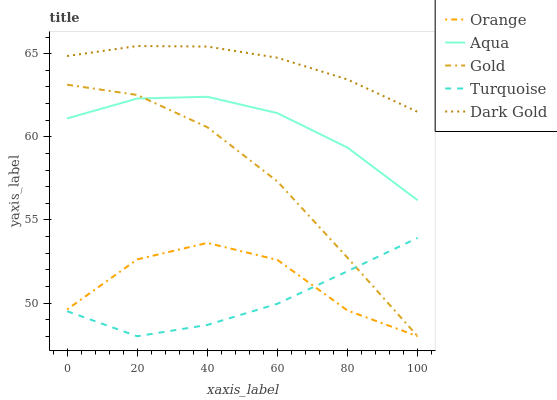Does Turquoise have the minimum area under the curve?
Answer yes or no. Yes. Does Dark Gold have the maximum area under the curve?
Answer yes or no. Yes. Does Aqua have the minimum area under the curve?
Answer yes or no. No. Does Aqua have the maximum area under the curve?
Answer yes or no. No. Is Dark Gold the smoothest?
Answer yes or no. Yes. Is Orange the roughest?
Answer yes or no. Yes. Is Turquoise the smoothest?
Answer yes or no. No. Is Turquoise the roughest?
Answer yes or no. No. Does Orange have the lowest value?
Answer yes or no. Yes. Does Aqua have the lowest value?
Answer yes or no. No. Does Dark Gold have the highest value?
Answer yes or no. Yes. Does Turquoise have the highest value?
Answer yes or no. No. Is Orange less than Dark Gold?
Answer yes or no. Yes. Is Dark Gold greater than Turquoise?
Answer yes or no. Yes. Does Gold intersect Orange?
Answer yes or no. Yes. Is Gold less than Orange?
Answer yes or no. No. Is Gold greater than Orange?
Answer yes or no. No. Does Orange intersect Dark Gold?
Answer yes or no. No. 